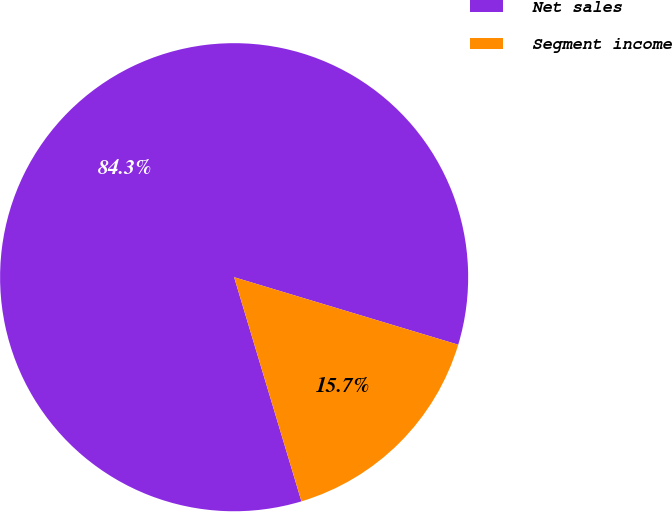<chart> <loc_0><loc_0><loc_500><loc_500><pie_chart><fcel>Net sales<fcel>Segment income<nl><fcel>84.3%<fcel>15.7%<nl></chart> 